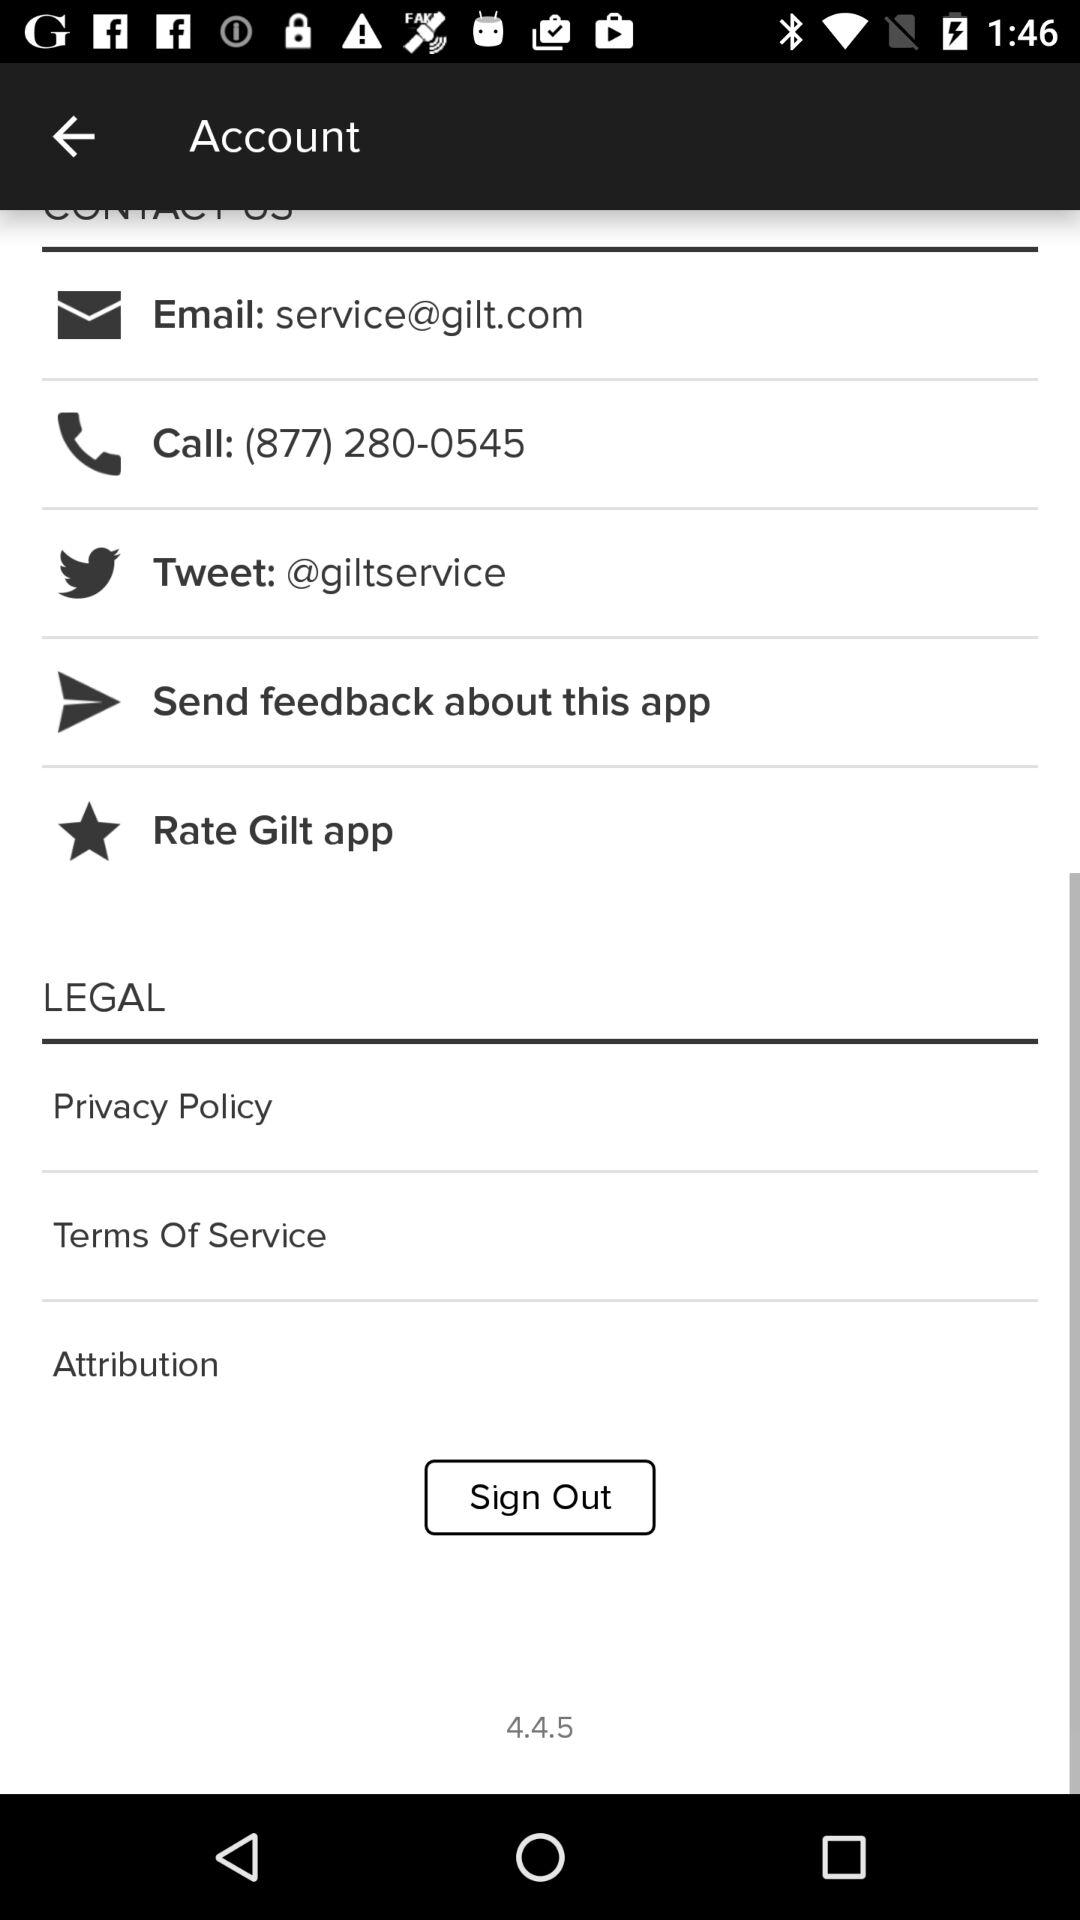When was the version updated?
When the provided information is insufficient, respond with <no answer>. <no answer> 